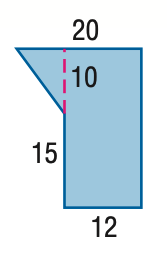Answer the mathemtical geometry problem and directly provide the correct option letter.
Question: Find the area of the figure. Round to the nearest tenth if necessary.
Choices: A: 230 B: 300 C: 340 D: 400 C 